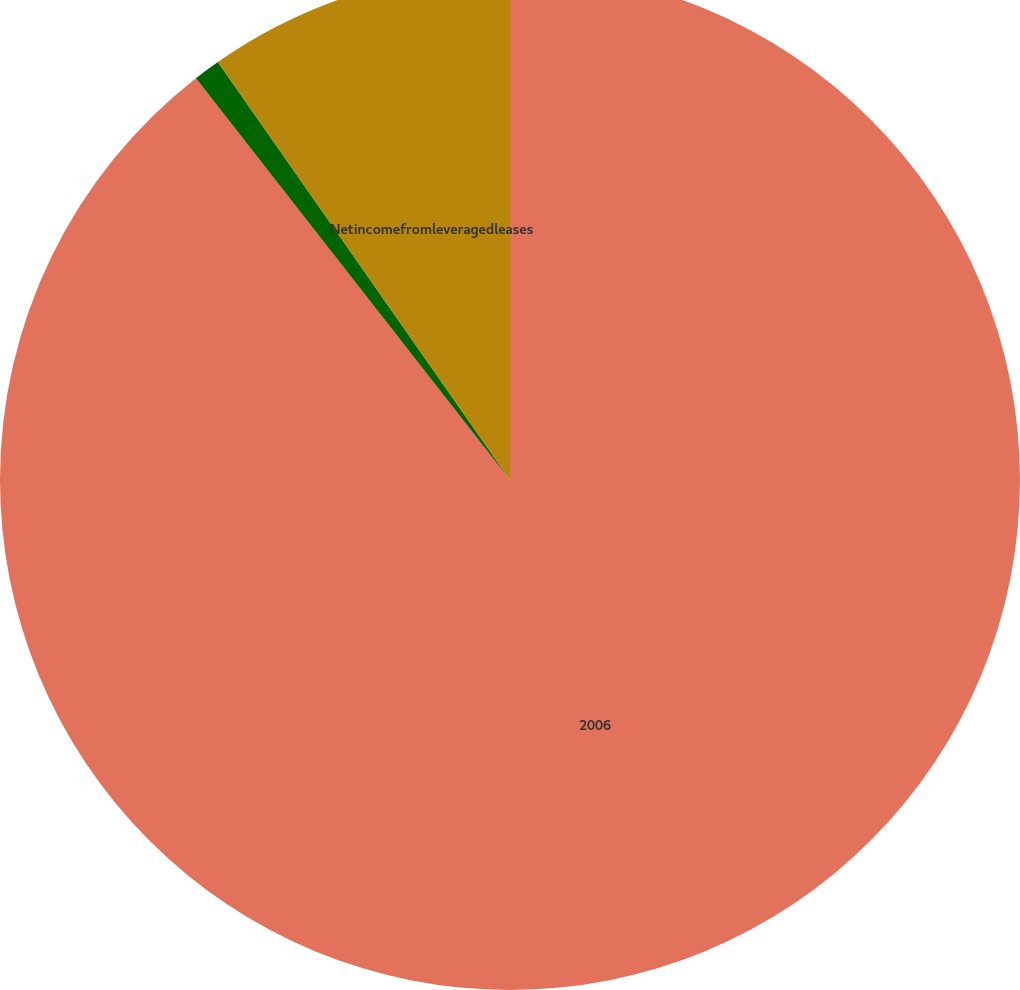Convert chart. <chart><loc_0><loc_0><loc_500><loc_500><pie_chart><fcel>2006<fcel>Unnamed: 1<fcel>Netincomefromleveragedleases<nl><fcel>89.45%<fcel>0.85%<fcel>9.71%<nl></chart> 